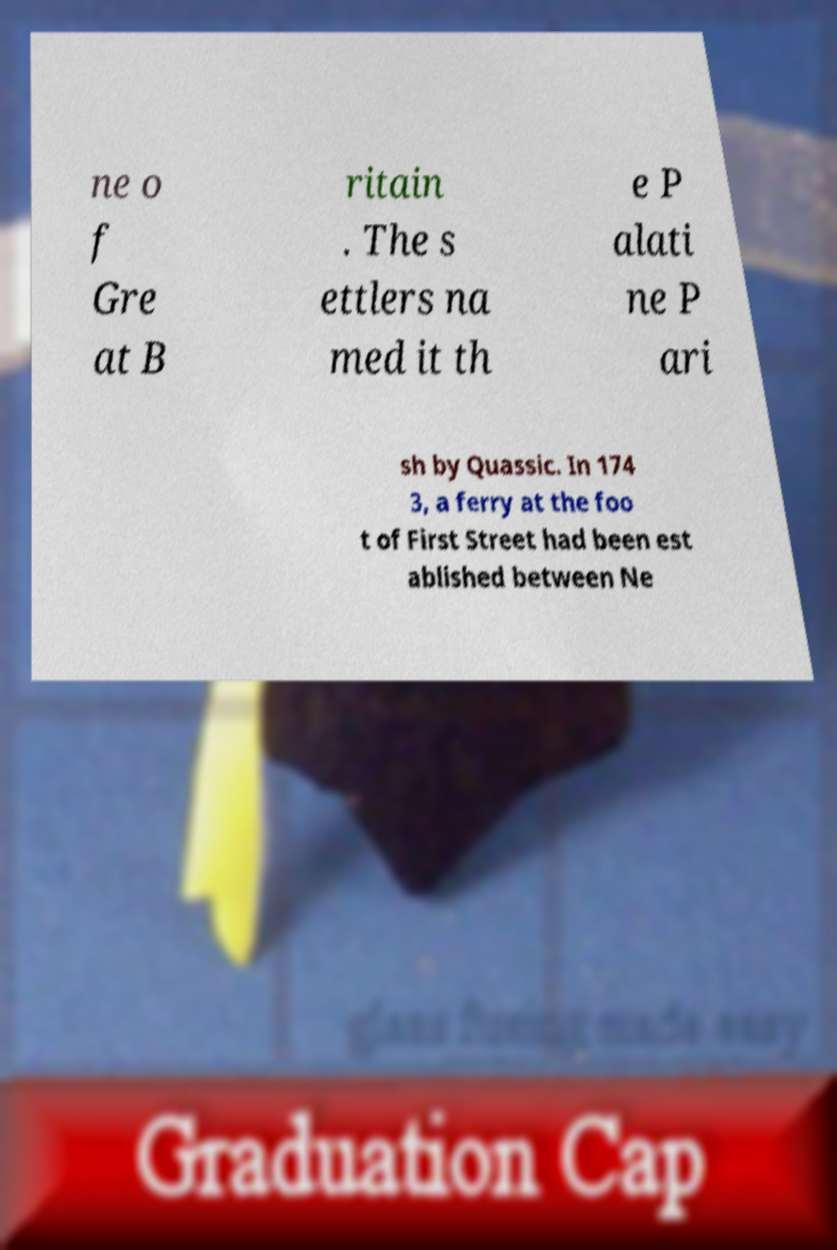I need the written content from this picture converted into text. Can you do that? ne o f Gre at B ritain . The s ettlers na med it th e P alati ne P ari sh by Quassic. In 174 3, a ferry at the foo t of First Street had been est ablished between Ne 